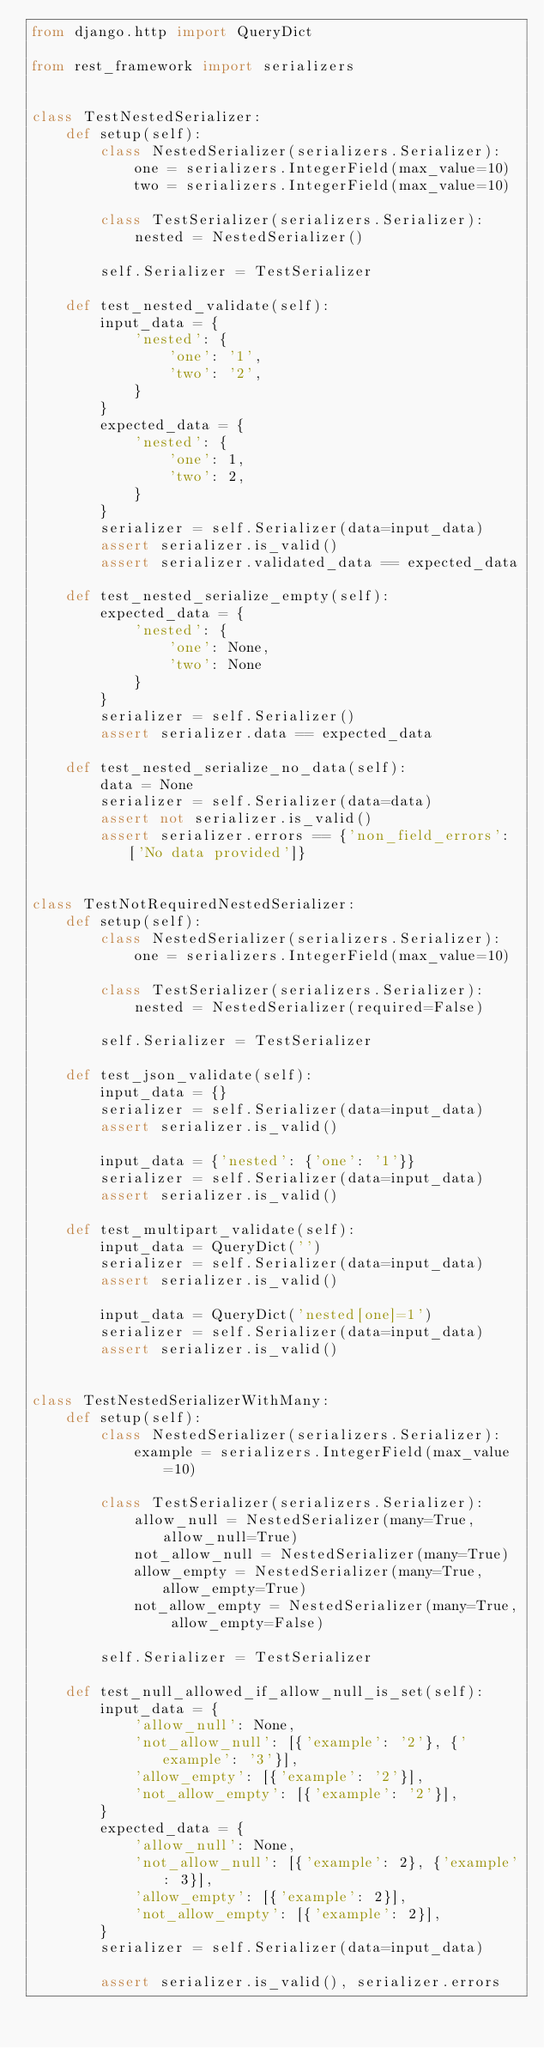Convert code to text. <code><loc_0><loc_0><loc_500><loc_500><_Python_>from django.http import QueryDict

from rest_framework import serializers


class TestNestedSerializer:
    def setup(self):
        class NestedSerializer(serializers.Serializer):
            one = serializers.IntegerField(max_value=10)
            two = serializers.IntegerField(max_value=10)

        class TestSerializer(serializers.Serializer):
            nested = NestedSerializer()

        self.Serializer = TestSerializer

    def test_nested_validate(self):
        input_data = {
            'nested': {
                'one': '1',
                'two': '2',
            }
        }
        expected_data = {
            'nested': {
                'one': 1,
                'two': 2,
            }
        }
        serializer = self.Serializer(data=input_data)
        assert serializer.is_valid()
        assert serializer.validated_data == expected_data

    def test_nested_serialize_empty(self):
        expected_data = {
            'nested': {
                'one': None,
                'two': None
            }
        }
        serializer = self.Serializer()
        assert serializer.data == expected_data

    def test_nested_serialize_no_data(self):
        data = None
        serializer = self.Serializer(data=data)
        assert not serializer.is_valid()
        assert serializer.errors == {'non_field_errors': ['No data provided']}


class TestNotRequiredNestedSerializer:
    def setup(self):
        class NestedSerializer(serializers.Serializer):
            one = serializers.IntegerField(max_value=10)

        class TestSerializer(serializers.Serializer):
            nested = NestedSerializer(required=False)

        self.Serializer = TestSerializer

    def test_json_validate(self):
        input_data = {}
        serializer = self.Serializer(data=input_data)
        assert serializer.is_valid()

        input_data = {'nested': {'one': '1'}}
        serializer = self.Serializer(data=input_data)
        assert serializer.is_valid()

    def test_multipart_validate(self):
        input_data = QueryDict('')
        serializer = self.Serializer(data=input_data)
        assert serializer.is_valid()

        input_data = QueryDict('nested[one]=1')
        serializer = self.Serializer(data=input_data)
        assert serializer.is_valid()


class TestNestedSerializerWithMany:
    def setup(self):
        class NestedSerializer(serializers.Serializer):
            example = serializers.IntegerField(max_value=10)

        class TestSerializer(serializers.Serializer):
            allow_null = NestedSerializer(many=True, allow_null=True)
            not_allow_null = NestedSerializer(many=True)
            allow_empty = NestedSerializer(many=True, allow_empty=True)
            not_allow_empty = NestedSerializer(many=True, allow_empty=False)

        self.Serializer = TestSerializer

    def test_null_allowed_if_allow_null_is_set(self):
        input_data = {
            'allow_null': None,
            'not_allow_null': [{'example': '2'}, {'example': '3'}],
            'allow_empty': [{'example': '2'}],
            'not_allow_empty': [{'example': '2'}],
        }
        expected_data = {
            'allow_null': None,
            'not_allow_null': [{'example': 2}, {'example': 3}],
            'allow_empty': [{'example': 2}],
            'not_allow_empty': [{'example': 2}],
        }
        serializer = self.Serializer(data=input_data)

        assert serializer.is_valid(), serializer.errors</code> 